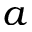<formula> <loc_0><loc_0><loc_500><loc_500>a</formula> 